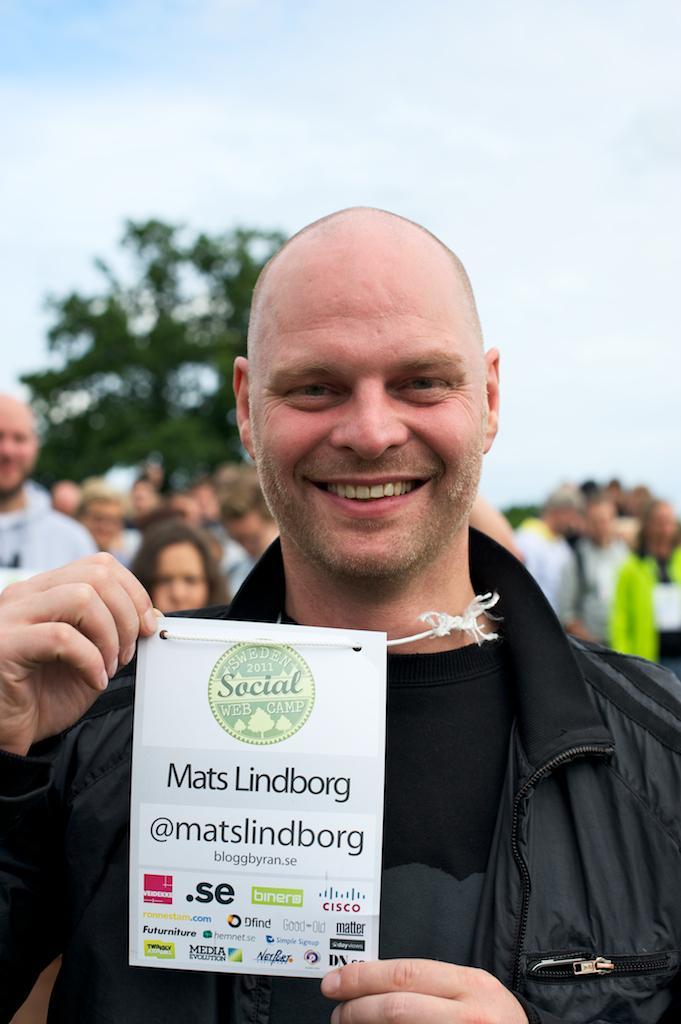Please provide a concise description of this image. In the picture we can see a man with a bald head and black jacket and holding a card with some information in it and behind him we can see some people are standing and watching him and behind them we can see a tree and the sky. 